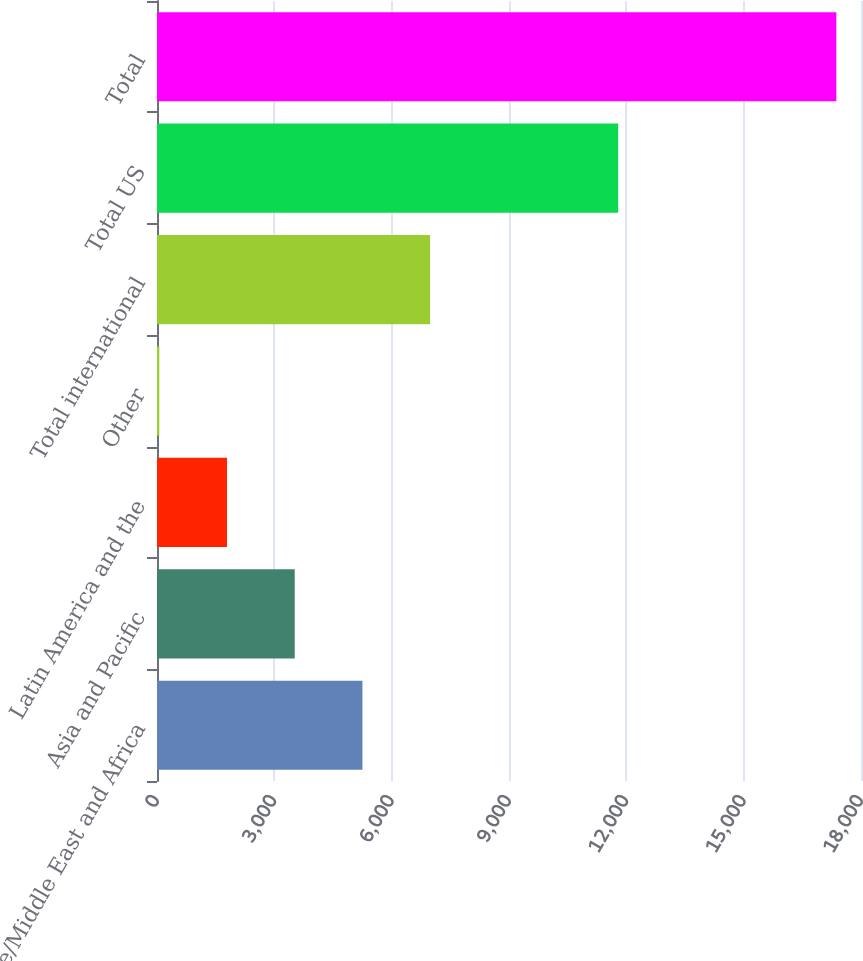<chart> <loc_0><loc_0><loc_500><loc_500><bar_chart><fcel>Europe/Middle East and Africa<fcel>Asia and Pacific<fcel>Latin America and the<fcel>Other<fcel>Total international<fcel>Total US<fcel>Total<nl><fcel>5252.3<fcel>3521.2<fcel>1790.1<fcel>59<fcel>6983.4<fcel>11791<fcel>17370<nl></chart> 